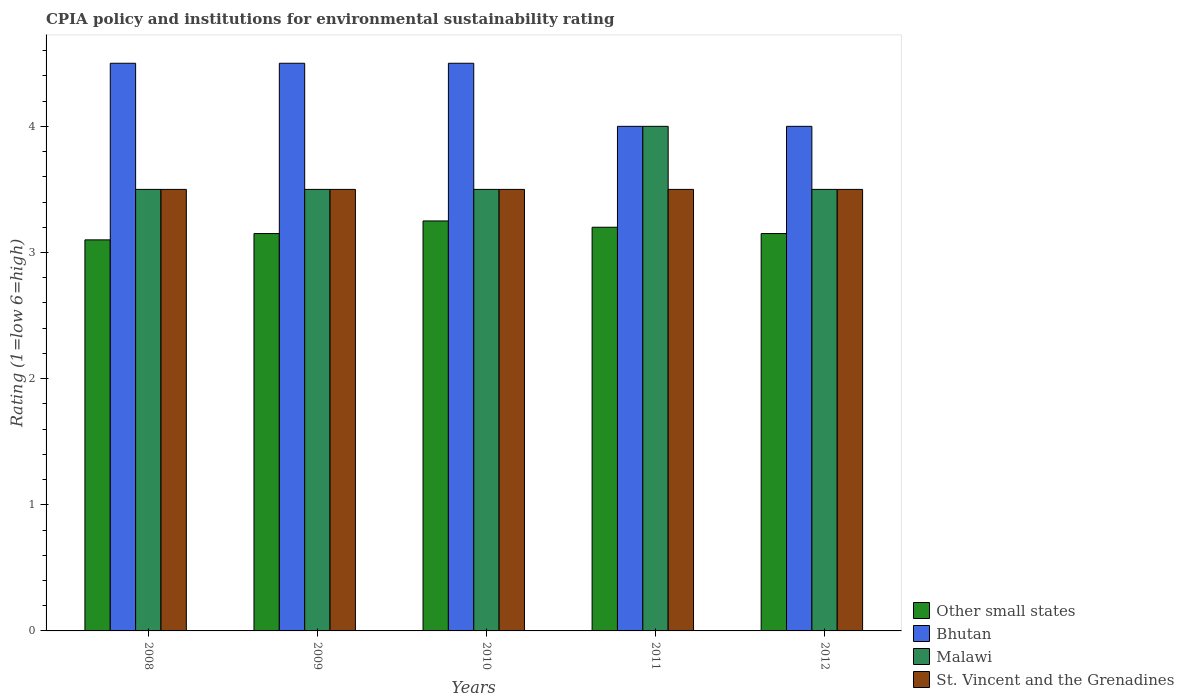How many different coloured bars are there?
Offer a terse response. 4. How many groups of bars are there?
Give a very brief answer. 5. Are the number of bars per tick equal to the number of legend labels?
Your answer should be compact. Yes. Are the number of bars on each tick of the X-axis equal?
Provide a short and direct response. Yes. How many bars are there on the 3rd tick from the left?
Your answer should be very brief. 4. How many bars are there on the 1st tick from the right?
Keep it short and to the point. 4. What is the CPIA rating in Malawi in 2009?
Provide a succinct answer. 3.5. Across all years, what is the minimum CPIA rating in Other small states?
Provide a short and direct response. 3.1. In which year was the CPIA rating in Other small states maximum?
Give a very brief answer. 2010. In which year was the CPIA rating in Bhutan minimum?
Keep it short and to the point. 2011. What is the total CPIA rating in Bhutan in the graph?
Give a very brief answer. 21.5. What is the difference between the CPIA rating in Bhutan in 2011 and the CPIA rating in Malawi in 2010?
Make the answer very short. 0.5. What is the average CPIA rating in Bhutan per year?
Provide a succinct answer. 4.3. What is the ratio of the CPIA rating in Other small states in 2009 to that in 2010?
Your answer should be compact. 0.97. Is the CPIA rating in Bhutan in 2009 less than that in 2010?
Your response must be concise. No. What is the difference between the highest and the second highest CPIA rating in Other small states?
Your response must be concise. 0.05. What is the difference between the highest and the lowest CPIA rating in Other small states?
Make the answer very short. 0.15. What does the 3rd bar from the left in 2008 represents?
Ensure brevity in your answer.  Malawi. What does the 2nd bar from the right in 2010 represents?
Make the answer very short. Malawi. Is it the case that in every year, the sum of the CPIA rating in Bhutan and CPIA rating in Malawi is greater than the CPIA rating in Other small states?
Give a very brief answer. Yes. How many bars are there?
Make the answer very short. 20. Are the values on the major ticks of Y-axis written in scientific E-notation?
Provide a succinct answer. No. Does the graph contain any zero values?
Provide a succinct answer. No. Where does the legend appear in the graph?
Ensure brevity in your answer.  Bottom right. How are the legend labels stacked?
Your response must be concise. Vertical. What is the title of the graph?
Make the answer very short. CPIA policy and institutions for environmental sustainability rating. Does "Sweden" appear as one of the legend labels in the graph?
Offer a terse response. No. What is the label or title of the Y-axis?
Keep it short and to the point. Rating (1=low 6=high). What is the Rating (1=low 6=high) in Other small states in 2008?
Make the answer very short. 3.1. What is the Rating (1=low 6=high) in Other small states in 2009?
Offer a terse response. 3.15. What is the Rating (1=low 6=high) in Bhutan in 2009?
Ensure brevity in your answer.  4.5. What is the Rating (1=low 6=high) in Malawi in 2009?
Your response must be concise. 3.5. What is the Rating (1=low 6=high) of Other small states in 2010?
Offer a very short reply. 3.25. What is the Rating (1=low 6=high) of St. Vincent and the Grenadines in 2010?
Make the answer very short. 3.5. What is the Rating (1=low 6=high) in Bhutan in 2011?
Offer a very short reply. 4. What is the Rating (1=low 6=high) in Other small states in 2012?
Make the answer very short. 3.15. What is the Rating (1=low 6=high) of Malawi in 2012?
Keep it short and to the point. 3.5. Across all years, what is the minimum Rating (1=low 6=high) of Other small states?
Your answer should be compact. 3.1. Across all years, what is the minimum Rating (1=low 6=high) in Bhutan?
Keep it short and to the point. 4. Across all years, what is the minimum Rating (1=low 6=high) in St. Vincent and the Grenadines?
Ensure brevity in your answer.  3.5. What is the total Rating (1=low 6=high) of Other small states in the graph?
Your answer should be compact. 15.85. What is the total Rating (1=low 6=high) of Malawi in the graph?
Provide a short and direct response. 18. What is the difference between the Rating (1=low 6=high) of Bhutan in 2008 and that in 2009?
Your answer should be very brief. 0. What is the difference between the Rating (1=low 6=high) of Malawi in 2008 and that in 2009?
Your response must be concise. 0. What is the difference between the Rating (1=low 6=high) of Other small states in 2008 and that in 2010?
Keep it short and to the point. -0.15. What is the difference between the Rating (1=low 6=high) in Malawi in 2008 and that in 2010?
Your answer should be very brief. 0. What is the difference between the Rating (1=low 6=high) of St. Vincent and the Grenadines in 2008 and that in 2010?
Provide a short and direct response. 0. What is the difference between the Rating (1=low 6=high) in Malawi in 2008 and that in 2011?
Your answer should be very brief. -0.5. What is the difference between the Rating (1=low 6=high) of St. Vincent and the Grenadines in 2008 and that in 2011?
Your response must be concise. 0. What is the difference between the Rating (1=low 6=high) of Malawi in 2008 and that in 2012?
Your response must be concise. 0. What is the difference between the Rating (1=low 6=high) of Bhutan in 2009 and that in 2010?
Make the answer very short. 0. What is the difference between the Rating (1=low 6=high) in Malawi in 2009 and that in 2010?
Provide a short and direct response. 0. What is the difference between the Rating (1=low 6=high) of St. Vincent and the Grenadines in 2009 and that in 2010?
Provide a succinct answer. 0. What is the difference between the Rating (1=low 6=high) in Other small states in 2009 and that in 2011?
Ensure brevity in your answer.  -0.05. What is the difference between the Rating (1=low 6=high) of Malawi in 2009 and that in 2011?
Make the answer very short. -0.5. What is the difference between the Rating (1=low 6=high) in Other small states in 2009 and that in 2012?
Offer a terse response. 0. What is the difference between the Rating (1=low 6=high) in Malawi in 2009 and that in 2012?
Your response must be concise. 0. What is the difference between the Rating (1=low 6=high) of St. Vincent and the Grenadines in 2009 and that in 2012?
Make the answer very short. 0. What is the difference between the Rating (1=low 6=high) in Other small states in 2010 and that in 2011?
Ensure brevity in your answer.  0.05. What is the difference between the Rating (1=low 6=high) of Bhutan in 2010 and that in 2011?
Ensure brevity in your answer.  0.5. What is the difference between the Rating (1=low 6=high) in St. Vincent and the Grenadines in 2010 and that in 2011?
Keep it short and to the point. 0. What is the difference between the Rating (1=low 6=high) in Malawi in 2010 and that in 2012?
Provide a short and direct response. 0. What is the difference between the Rating (1=low 6=high) in Other small states in 2011 and that in 2012?
Ensure brevity in your answer.  0.05. What is the difference between the Rating (1=low 6=high) of Malawi in 2011 and that in 2012?
Your answer should be very brief. 0.5. What is the difference between the Rating (1=low 6=high) of St. Vincent and the Grenadines in 2011 and that in 2012?
Give a very brief answer. 0. What is the difference between the Rating (1=low 6=high) of Other small states in 2008 and the Rating (1=low 6=high) of Bhutan in 2009?
Offer a terse response. -1.4. What is the difference between the Rating (1=low 6=high) of Bhutan in 2008 and the Rating (1=low 6=high) of Malawi in 2009?
Provide a succinct answer. 1. What is the difference between the Rating (1=low 6=high) in Malawi in 2008 and the Rating (1=low 6=high) in St. Vincent and the Grenadines in 2009?
Your answer should be compact. 0. What is the difference between the Rating (1=low 6=high) of Other small states in 2008 and the Rating (1=low 6=high) of Malawi in 2010?
Offer a terse response. -0.4. What is the difference between the Rating (1=low 6=high) of Malawi in 2008 and the Rating (1=low 6=high) of St. Vincent and the Grenadines in 2010?
Give a very brief answer. 0. What is the difference between the Rating (1=low 6=high) of Other small states in 2008 and the Rating (1=low 6=high) of Malawi in 2011?
Your response must be concise. -0.9. What is the difference between the Rating (1=low 6=high) of Bhutan in 2008 and the Rating (1=low 6=high) of St. Vincent and the Grenadines in 2011?
Your answer should be compact. 1. What is the difference between the Rating (1=low 6=high) in Malawi in 2008 and the Rating (1=low 6=high) in St. Vincent and the Grenadines in 2011?
Your answer should be very brief. 0. What is the difference between the Rating (1=low 6=high) of Other small states in 2008 and the Rating (1=low 6=high) of Bhutan in 2012?
Your response must be concise. -0.9. What is the difference between the Rating (1=low 6=high) in Other small states in 2008 and the Rating (1=low 6=high) in St. Vincent and the Grenadines in 2012?
Your answer should be compact. -0.4. What is the difference between the Rating (1=low 6=high) in Bhutan in 2008 and the Rating (1=low 6=high) in Malawi in 2012?
Provide a succinct answer. 1. What is the difference between the Rating (1=low 6=high) of Bhutan in 2008 and the Rating (1=low 6=high) of St. Vincent and the Grenadines in 2012?
Offer a terse response. 1. What is the difference between the Rating (1=low 6=high) in Malawi in 2008 and the Rating (1=low 6=high) in St. Vincent and the Grenadines in 2012?
Your answer should be compact. 0. What is the difference between the Rating (1=low 6=high) of Other small states in 2009 and the Rating (1=low 6=high) of Bhutan in 2010?
Offer a terse response. -1.35. What is the difference between the Rating (1=low 6=high) of Other small states in 2009 and the Rating (1=low 6=high) of Malawi in 2010?
Provide a succinct answer. -0.35. What is the difference between the Rating (1=low 6=high) in Other small states in 2009 and the Rating (1=low 6=high) in St. Vincent and the Grenadines in 2010?
Your answer should be very brief. -0.35. What is the difference between the Rating (1=low 6=high) of Bhutan in 2009 and the Rating (1=low 6=high) of Malawi in 2010?
Offer a terse response. 1. What is the difference between the Rating (1=low 6=high) in Other small states in 2009 and the Rating (1=low 6=high) in Bhutan in 2011?
Your answer should be very brief. -0.85. What is the difference between the Rating (1=low 6=high) of Other small states in 2009 and the Rating (1=low 6=high) of Malawi in 2011?
Your response must be concise. -0.85. What is the difference between the Rating (1=low 6=high) in Other small states in 2009 and the Rating (1=low 6=high) in St. Vincent and the Grenadines in 2011?
Make the answer very short. -0.35. What is the difference between the Rating (1=low 6=high) in Malawi in 2009 and the Rating (1=low 6=high) in St. Vincent and the Grenadines in 2011?
Your response must be concise. 0. What is the difference between the Rating (1=low 6=high) in Other small states in 2009 and the Rating (1=low 6=high) in Bhutan in 2012?
Provide a succinct answer. -0.85. What is the difference between the Rating (1=low 6=high) in Other small states in 2009 and the Rating (1=low 6=high) in Malawi in 2012?
Your answer should be very brief. -0.35. What is the difference between the Rating (1=low 6=high) of Other small states in 2009 and the Rating (1=low 6=high) of St. Vincent and the Grenadines in 2012?
Provide a short and direct response. -0.35. What is the difference between the Rating (1=low 6=high) in Malawi in 2009 and the Rating (1=low 6=high) in St. Vincent and the Grenadines in 2012?
Provide a succinct answer. 0. What is the difference between the Rating (1=low 6=high) of Other small states in 2010 and the Rating (1=low 6=high) of Bhutan in 2011?
Ensure brevity in your answer.  -0.75. What is the difference between the Rating (1=low 6=high) in Other small states in 2010 and the Rating (1=low 6=high) in Malawi in 2011?
Make the answer very short. -0.75. What is the difference between the Rating (1=low 6=high) in Bhutan in 2010 and the Rating (1=low 6=high) in Malawi in 2011?
Ensure brevity in your answer.  0.5. What is the difference between the Rating (1=low 6=high) of Other small states in 2010 and the Rating (1=low 6=high) of Bhutan in 2012?
Your response must be concise. -0.75. What is the difference between the Rating (1=low 6=high) in Other small states in 2010 and the Rating (1=low 6=high) in St. Vincent and the Grenadines in 2012?
Ensure brevity in your answer.  -0.25. What is the difference between the Rating (1=low 6=high) of Bhutan in 2010 and the Rating (1=low 6=high) of Malawi in 2012?
Provide a short and direct response. 1. What is the difference between the Rating (1=low 6=high) in Bhutan in 2010 and the Rating (1=low 6=high) in St. Vincent and the Grenadines in 2012?
Make the answer very short. 1. What is the difference between the Rating (1=low 6=high) in Other small states in 2011 and the Rating (1=low 6=high) in Malawi in 2012?
Provide a succinct answer. -0.3. What is the difference between the Rating (1=low 6=high) of Bhutan in 2011 and the Rating (1=low 6=high) of St. Vincent and the Grenadines in 2012?
Your response must be concise. 0.5. What is the average Rating (1=low 6=high) in Other small states per year?
Your answer should be compact. 3.17. What is the average Rating (1=low 6=high) of Bhutan per year?
Offer a very short reply. 4.3. In the year 2008, what is the difference between the Rating (1=low 6=high) of Bhutan and Rating (1=low 6=high) of Malawi?
Your answer should be very brief. 1. In the year 2008, what is the difference between the Rating (1=low 6=high) of Malawi and Rating (1=low 6=high) of St. Vincent and the Grenadines?
Offer a very short reply. 0. In the year 2009, what is the difference between the Rating (1=low 6=high) of Other small states and Rating (1=low 6=high) of Bhutan?
Give a very brief answer. -1.35. In the year 2009, what is the difference between the Rating (1=low 6=high) in Other small states and Rating (1=low 6=high) in Malawi?
Your answer should be compact. -0.35. In the year 2009, what is the difference between the Rating (1=low 6=high) in Other small states and Rating (1=low 6=high) in St. Vincent and the Grenadines?
Make the answer very short. -0.35. In the year 2010, what is the difference between the Rating (1=low 6=high) of Other small states and Rating (1=low 6=high) of Bhutan?
Provide a succinct answer. -1.25. In the year 2010, what is the difference between the Rating (1=low 6=high) in Other small states and Rating (1=low 6=high) in Malawi?
Ensure brevity in your answer.  -0.25. In the year 2010, what is the difference between the Rating (1=low 6=high) in Other small states and Rating (1=low 6=high) in St. Vincent and the Grenadines?
Offer a terse response. -0.25. In the year 2010, what is the difference between the Rating (1=low 6=high) of Bhutan and Rating (1=low 6=high) of Malawi?
Make the answer very short. 1. In the year 2011, what is the difference between the Rating (1=low 6=high) in Other small states and Rating (1=low 6=high) in Bhutan?
Provide a succinct answer. -0.8. In the year 2011, what is the difference between the Rating (1=low 6=high) of Bhutan and Rating (1=low 6=high) of Malawi?
Offer a terse response. 0. In the year 2011, what is the difference between the Rating (1=low 6=high) of Bhutan and Rating (1=low 6=high) of St. Vincent and the Grenadines?
Keep it short and to the point. 0.5. In the year 2011, what is the difference between the Rating (1=low 6=high) in Malawi and Rating (1=low 6=high) in St. Vincent and the Grenadines?
Provide a succinct answer. 0.5. In the year 2012, what is the difference between the Rating (1=low 6=high) of Other small states and Rating (1=low 6=high) of Bhutan?
Make the answer very short. -0.85. In the year 2012, what is the difference between the Rating (1=low 6=high) in Other small states and Rating (1=low 6=high) in Malawi?
Offer a terse response. -0.35. In the year 2012, what is the difference between the Rating (1=low 6=high) in Other small states and Rating (1=low 6=high) in St. Vincent and the Grenadines?
Give a very brief answer. -0.35. In the year 2012, what is the difference between the Rating (1=low 6=high) in Bhutan and Rating (1=low 6=high) in St. Vincent and the Grenadines?
Make the answer very short. 0.5. What is the ratio of the Rating (1=low 6=high) of Other small states in 2008 to that in 2009?
Make the answer very short. 0.98. What is the ratio of the Rating (1=low 6=high) in Other small states in 2008 to that in 2010?
Your answer should be compact. 0.95. What is the ratio of the Rating (1=low 6=high) in Bhutan in 2008 to that in 2010?
Your answer should be compact. 1. What is the ratio of the Rating (1=low 6=high) of Other small states in 2008 to that in 2011?
Your answer should be very brief. 0.97. What is the ratio of the Rating (1=low 6=high) in Bhutan in 2008 to that in 2011?
Your answer should be compact. 1.12. What is the ratio of the Rating (1=low 6=high) of Malawi in 2008 to that in 2011?
Offer a terse response. 0.88. What is the ratio of the Rating (1=low 6=high) of Other small states in 2008 to that in 2012?
Provide a succinct answer. 0.98. What is the ratio of the Rating (1=low 6=high) in Bhutan in 2008 to that in 2012?
Offer a terse response. 1.12. What is the ratio of the Rating (1=low 6=high) in Malawi in 2008 to that in 2012?
Offer a very short reply. 1. What is the ratio of the Rating (1=low 6=high) of St. Vincent and the Grenadines in 2008 to that in 2012?
Make the answer very short. 1. What is the ratio of the Rating (1=low 6=high) of Other small states in 2009 to that in 2010?
Your answer should be compact. 0.97. What is the ratio of the Rating (1=low 6=high) in Bhutan in 2009 to that in 2010?
Your response must be concise. 1. What is the ratio of the Rating (1=low 6=high) in Other small states in 2009 to that in 2011?
Provide a short and direct response. 0.98. What is the ratio of the Rating (1=low 6=high) in Malawi in 2009 to that in 2012?
Provide a short and direct response. 1. What is the ratio of the Rating (1=low 6=high) in Other small states in 2010 to that in 2011?
Offer a terse response. 1.02. What is the ratio of the Rating (1=low 6=high) of Bhutan in 2010 to that in 2011?
Provide a succinct answer. 1.12. What is the ratio of the Rating (1=low 6=high) of Other small states in 2010 to that in 2012?
Provide a succinct answer. 1.03. What is the ratio of the Rating (1=low 6=high) in Bhutan in 2010 to that in 2012?
Provide a succinct answer. 1.12. What is the ratio of the Rating (1=low 6=high) of Malawi in 2010 to that in 2012?
Ensure brevity in your answer.  1. What is the ratio of the Rating (1=low 6=high) in Other small states in 2011 to that in 2012?
Make the answer very short. 1.02. What is the ratio of the Rating (1=low 6=high) of St. Vincent and the Grenadines in 2011 to that in 2012?
Your answer should be very brief. 1. What is the difference between the highest and the second highest Rating (1=low 6=high) in Bhutan?
Make the answer very short. 0. What is the difference between the highest and the second highest Rating (1=low 6=high) in Malawi?
Keep it short and to the point. 0.5. What is the difference between the highest and the lowest Rating (1=low 6=high) in Bhutan?
Keep it short and to the point. 0.5. What is the difference between the highest and the lowest Rating (1=low 6=high) of Malawi?
Ensure brevity in your answer.  0.5. What is the difference between the highest and the lowest Rating (1=low 6=high) in St. Vincent and the Grenadines?
Offer a very short reply. 0. 